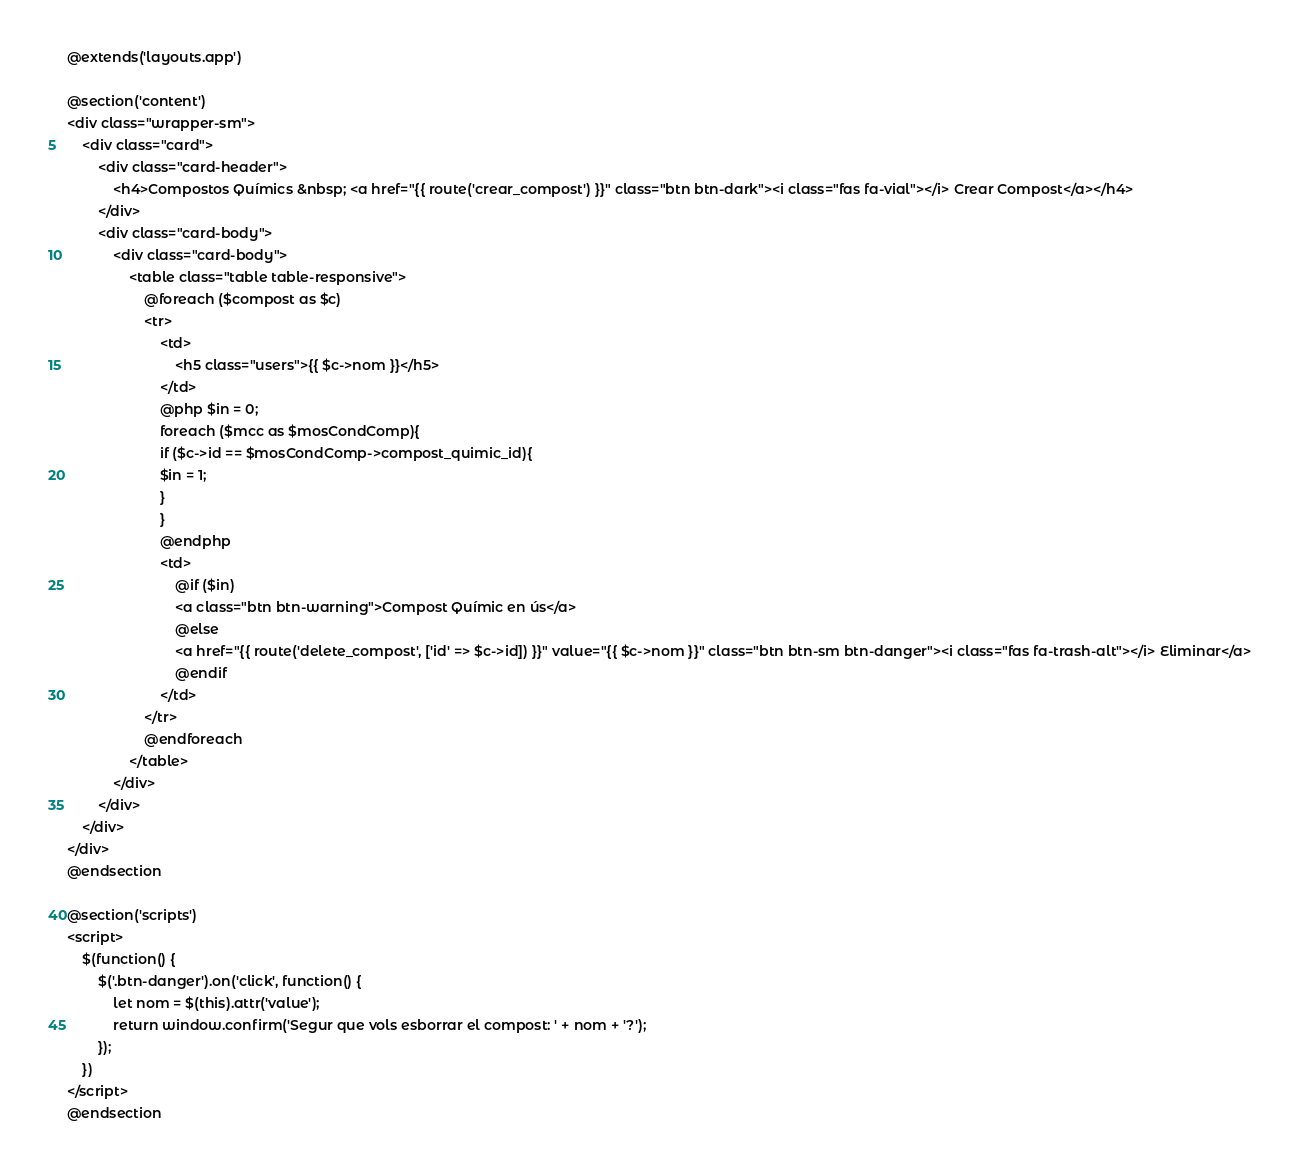Convert code to text. <code><loc_0><loc_0><loc_500><loc_500><_PHP_>@extends('layouts.app')

@section('content')
<div class="wrapper-sm">
    <div class="card">
        <div class="card-header">
            <h4>Compostos Químics &nbsp; <a href="{{ route('crear_compost') }}" class="btn btn-dark"><i class="fas fa-vial"></i> Crear Compost</a></h4>
        </div>
        <div class="card-body">
            <div class="card-body">
                <table class="table table-responsive">
                    @foreach ($compost as $c)
                    <tr>
                        <td>
                            <h5 class="users">{{ $c->nom }}</h5>
                        </td>
                        @php $in = 0;
                        foreach ($mcc as $mosCondComp){
                        if ($c->id == $mosCondComp->compost_quimic_id){
                        $in = 1;
                        }
                        }
                        @endphp
                        <td>
                            @if ($in)
                            <a class="btn btn-warning">Compost Químic en ús</a>
                            @else
                            <a href="{{ route('delete_compost', ['id' => $c->id]) }}" value="{{ $c->nom }}" class="btn btn-sm btn-danger"><i class="fas fa-trash-alt"></i> Eliminar</a>
                            @endif
                        </td>
                    </tr>
                    @endforeach
                </table>
            </div>
        </div>
    </div>
</div>
@endsection

@section('scripts')
<script>
    $(function() {
        $('.btn-danger').on('click', function() {
            let nom = $(this).attr('value');
            return window.confirm('Segur que vols esborrar el compost: ' + nom + '?');
        });
    })
</script>
@endsection</code> 